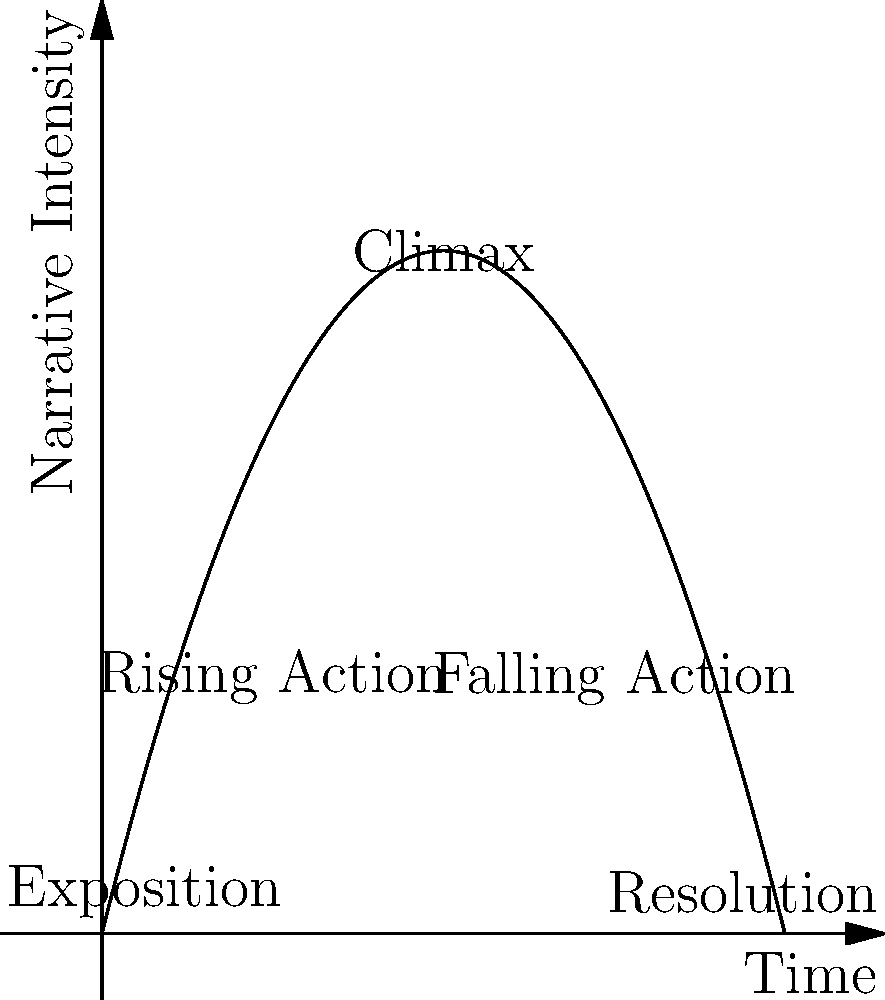In your latest novel, you want to visualize the narrative structure using a parabola. Given the parabolic function $f(x) = -0.5x^2 + 4x$, where $x$ represents time and $f(x)$ represents narrative intensity, at what point in the story does the climax occur? Express your answer in terms of $x$. To find the climax of the story, we need to determine the vertex of the parabola, which represents the highest point of narrative intensity. For a parabola in the form $f(x) = ax^2 + bx + c$, the x-coordinate of the vertex is given by $x = -\frac{b}{2a}$.

Step 1: Identify $a$ and $b$ in the given function $f(x) = -0.5x^2 + 4x$
$a = -0.5$
$b = 4$

Step 2: Apply the formula for the x-coordinate of the vertex
$x = -\frac{b}{2a} = -\frac{4}{2(-0.5)} = -\frac{4}{-1} = 4$

Therefore, the climax of the story occurs at $x = 4$, which represents the point in time when the narrative intensity reaches its peak.
Answer: $x = 4$ 